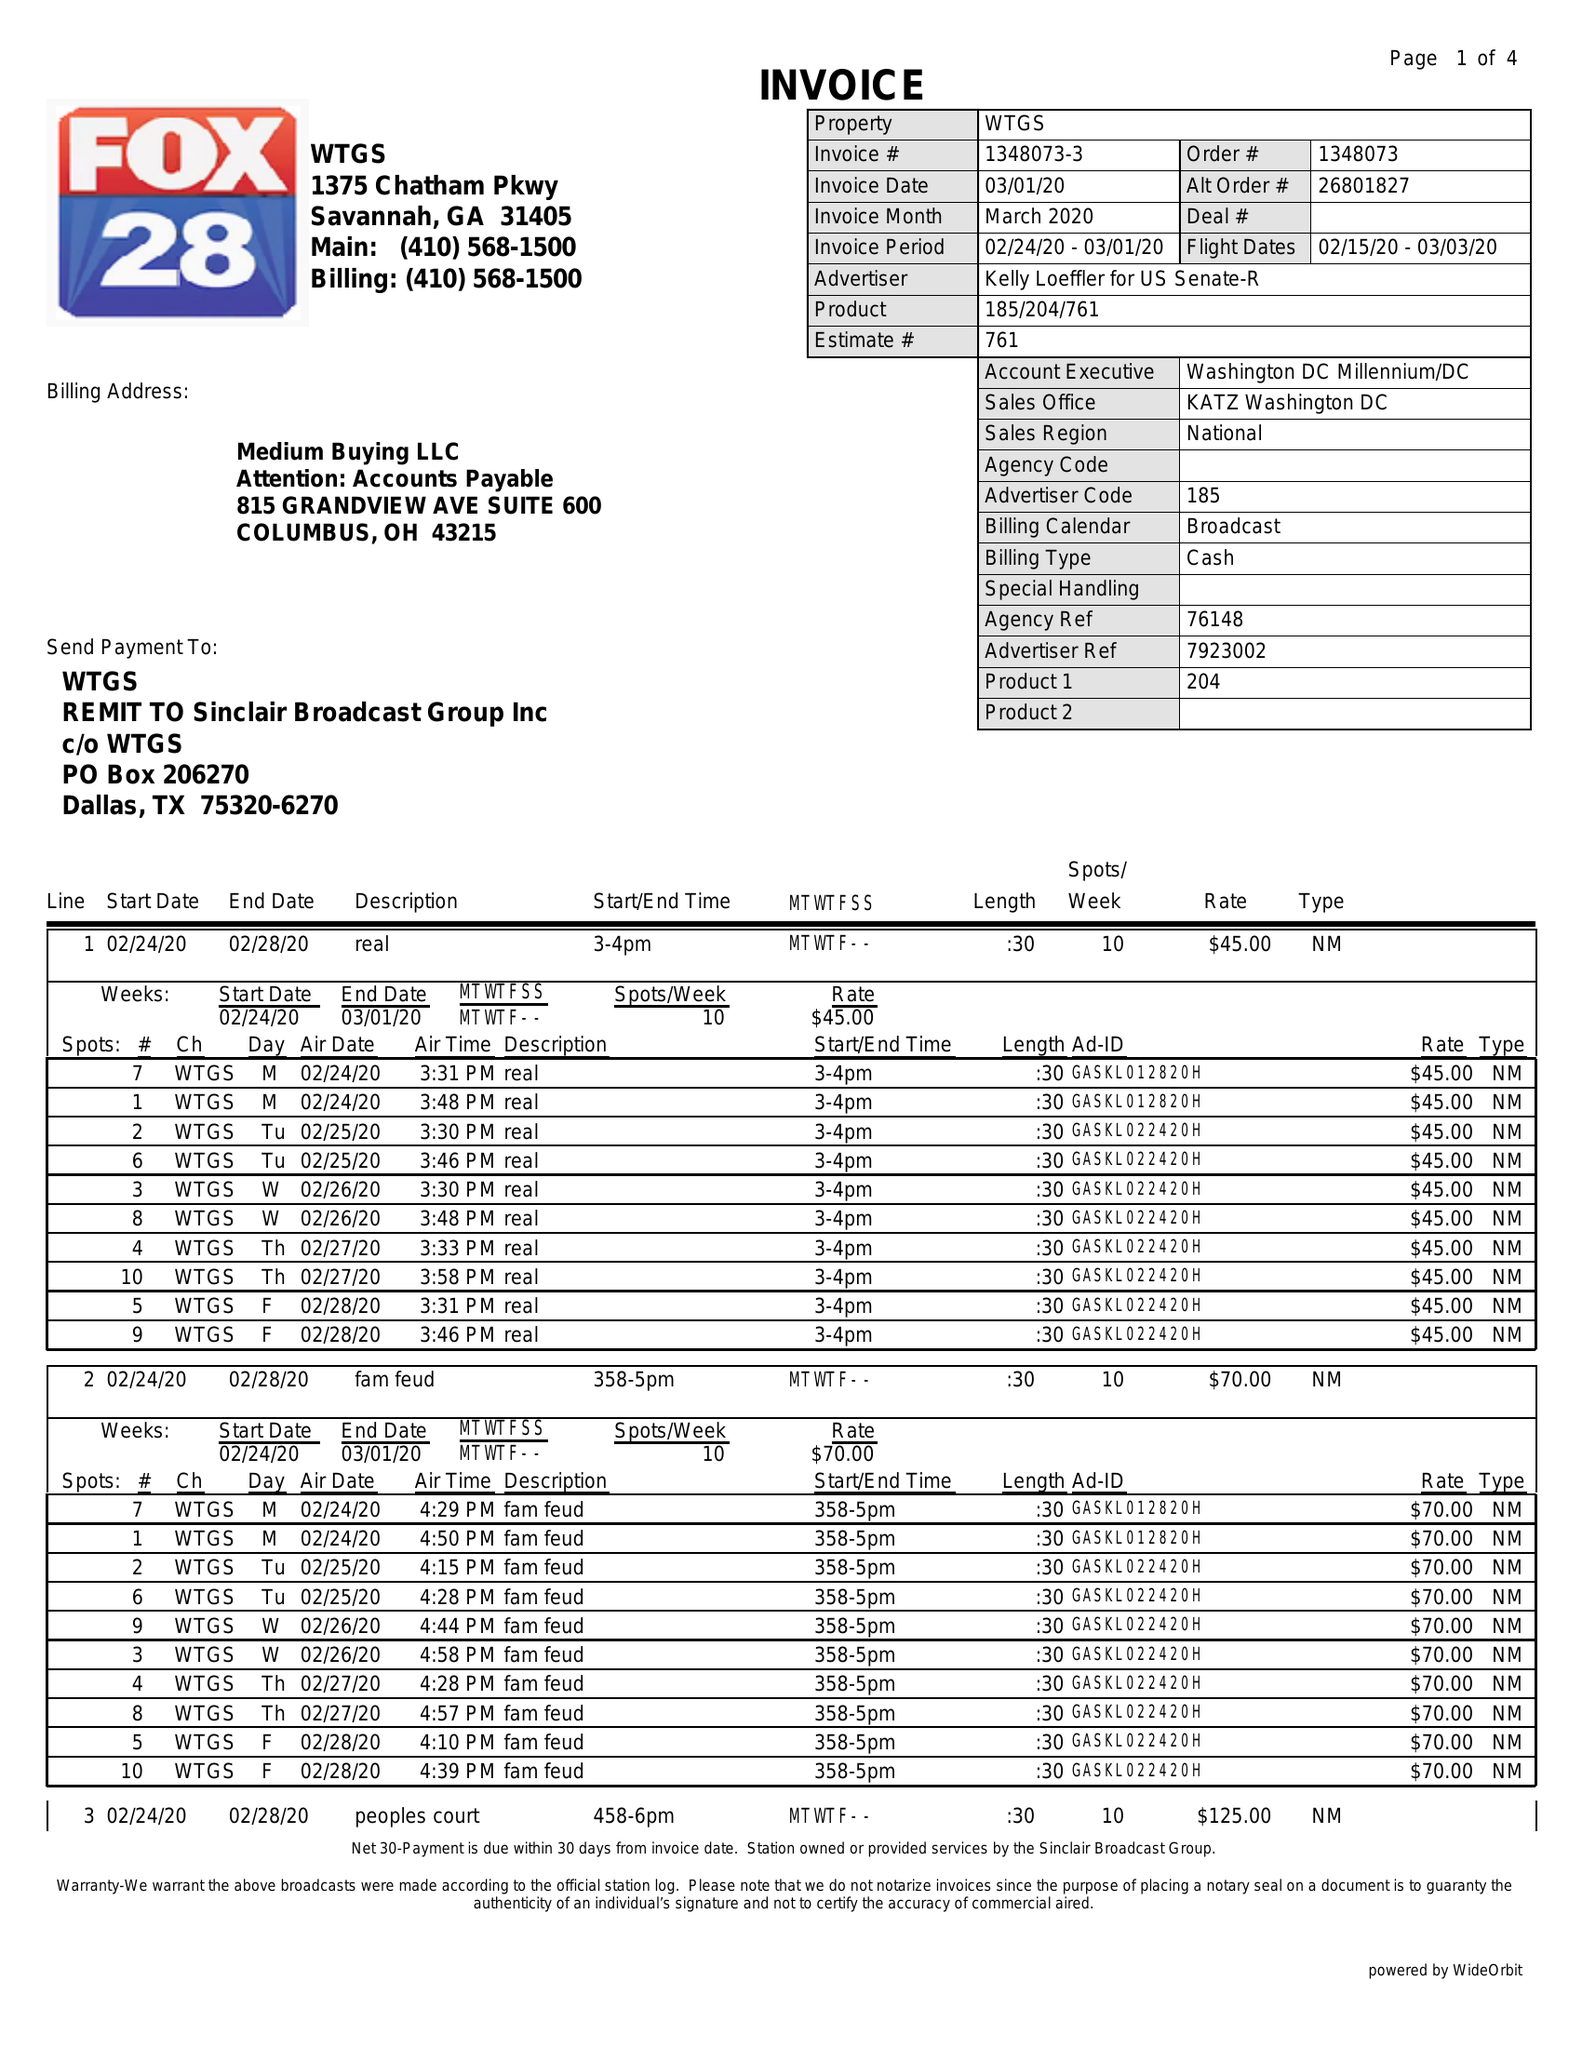What is the value for the gross_amount?
Answer the question using a single word or phrase. 5120.00 